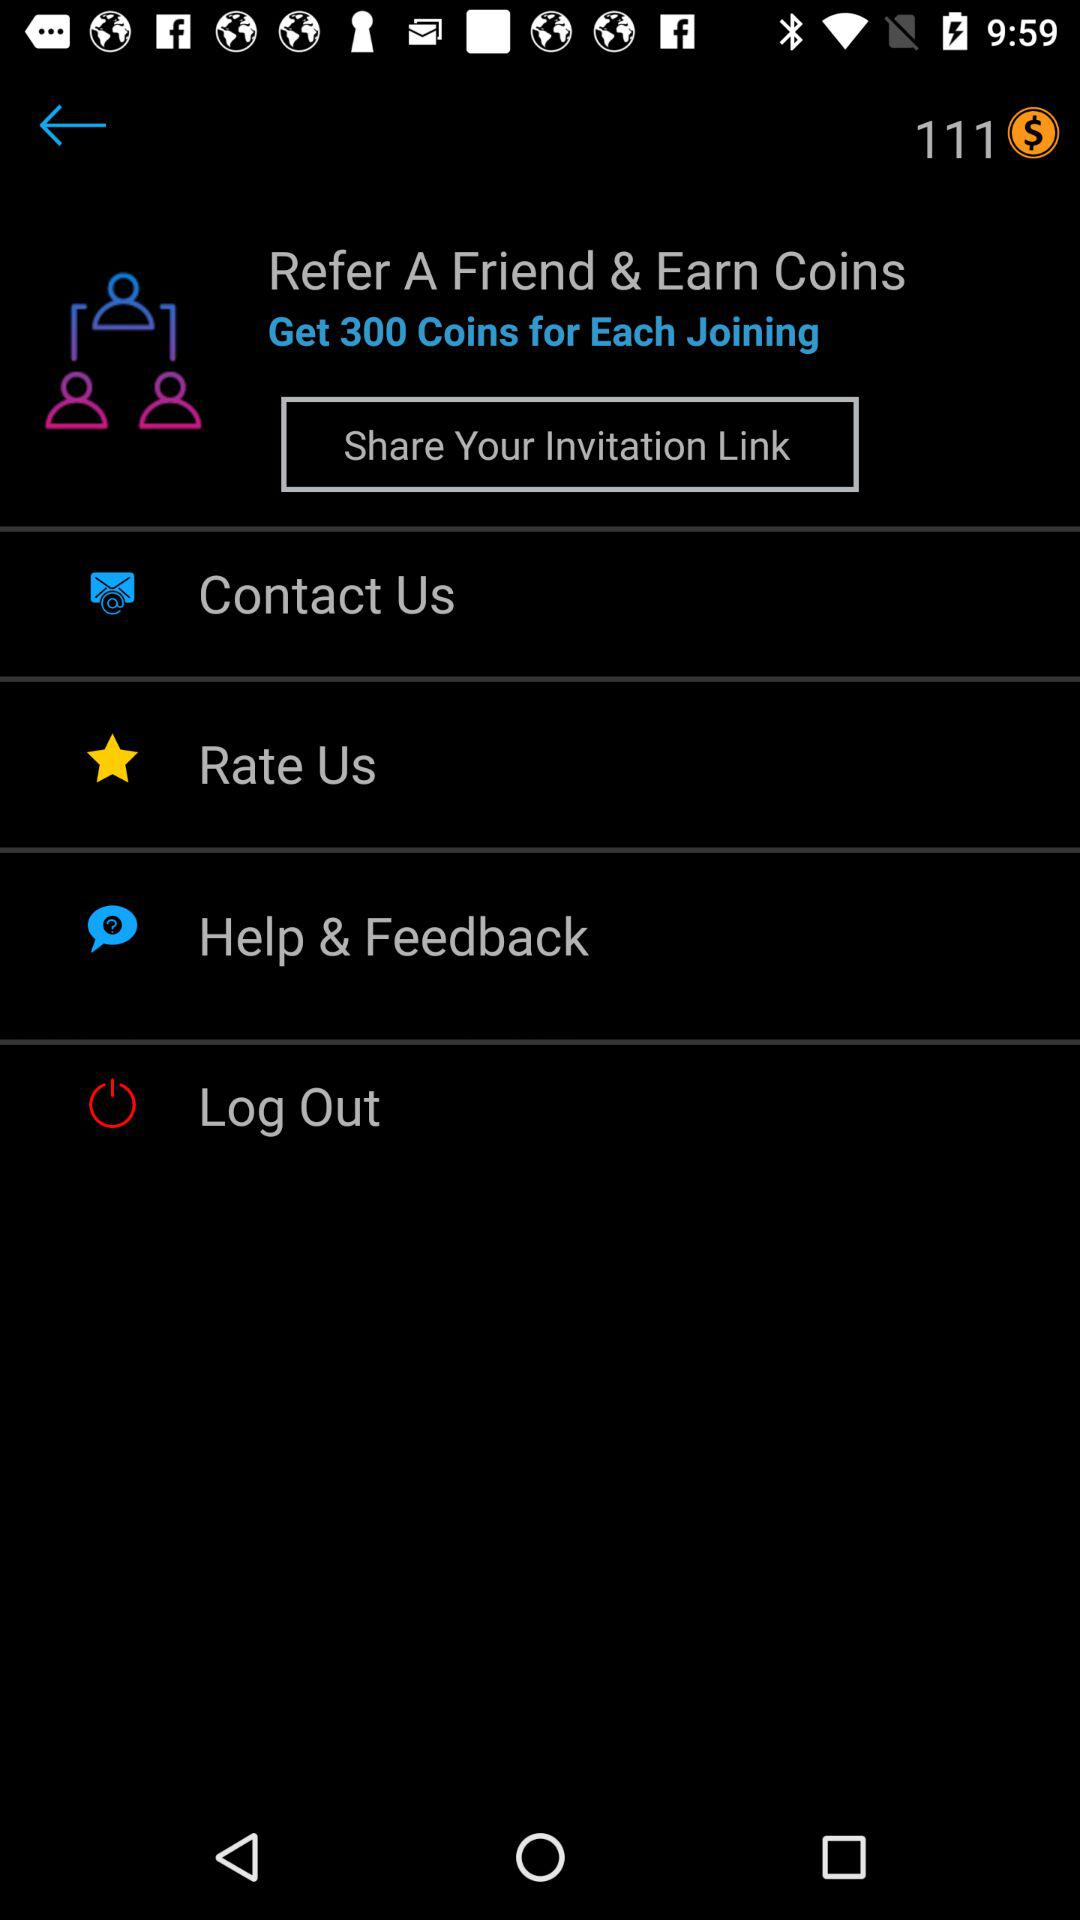What is the current balance in the account? The current balance is 111. 